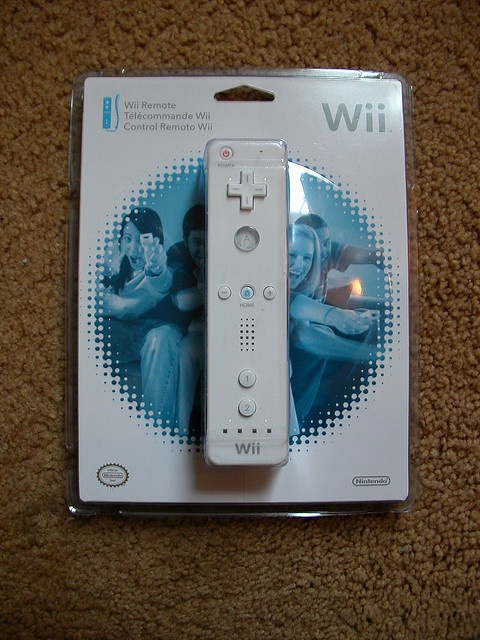Describe the objects in this image and their specific colors. I can see remote in black, darkgray, gray, and lightgray tones and people in black, teal, gray, blue, and darkblue tones in this image. 